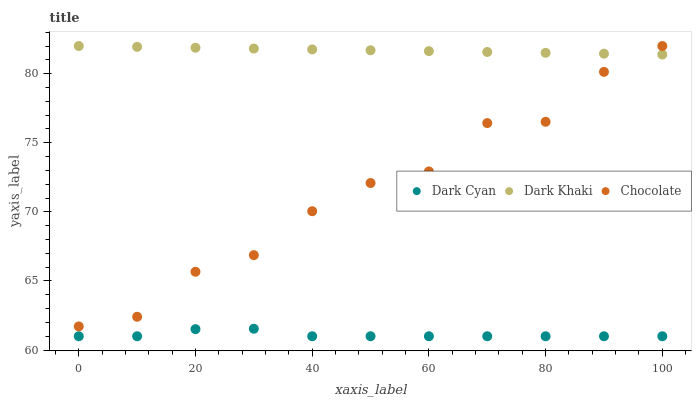Does Dark Cyan have the minimum area under the curve?
Answer yes or no. Yes. Does Dark Khaki have the maximum area under the curve?
Answer yes or no. Yes. Does Chocolate have the minimum area under the curve?
Answer yes or no. No. Does Chocolate have the maximum area under the curve?
Answer yes or no. No. Is Dark Khaki the smoothest?
Answer yes or no. Yes. Is Chocolate the roughest?
Answer yes or no. Yes. Is Chocolate the smoothest?
Answer yes or no. No. Is Dark Khaki the roughest?
Answer yes or no. No. Does Dark Cyan have the lowest value?
Answer yes or no. Yes. Does Chocolate have the lowest value?
Answer yes or no. No. Does Chocolate have the highest value?
Answer yes or no. Yes. Is Dark Cyan less than Chocolate?
Answer yes or no. Yes. Is Chocolate greater than Dark Cyan?
Answer yes or no. Yes. Does Chocolate intersect Dark Khaki?
Answer yes or no. Yes. Is Chocolate less than Dark Khaki?
Answer yes or no. No. Is Chocolate greater than Dark Khaki?
Answer yes or no. No. Does Dark Cyan intersect Chocolate?
Answer yes or no. No. 